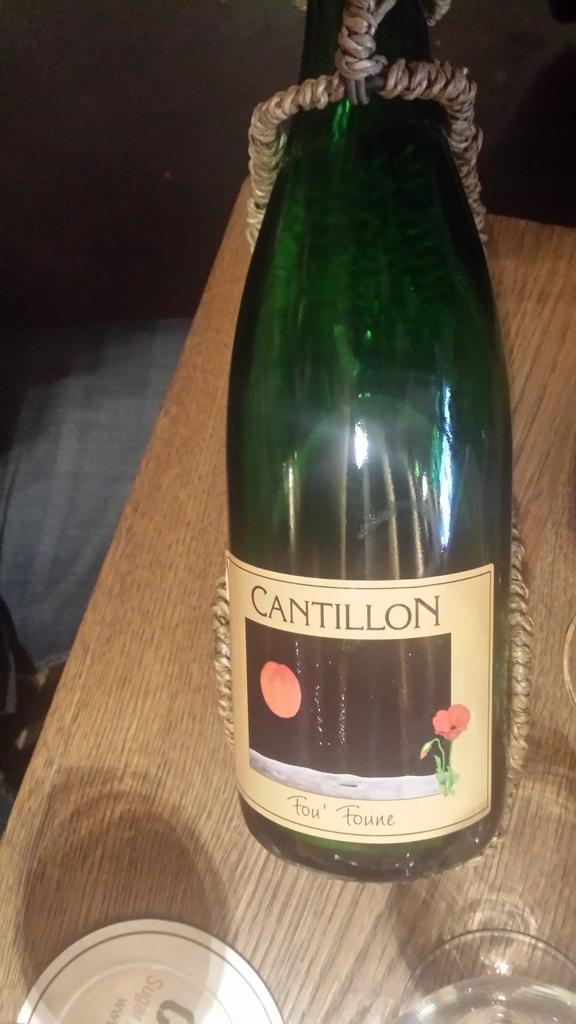<image>
Describe the image concisely. the word cantillon that is on a bottle 